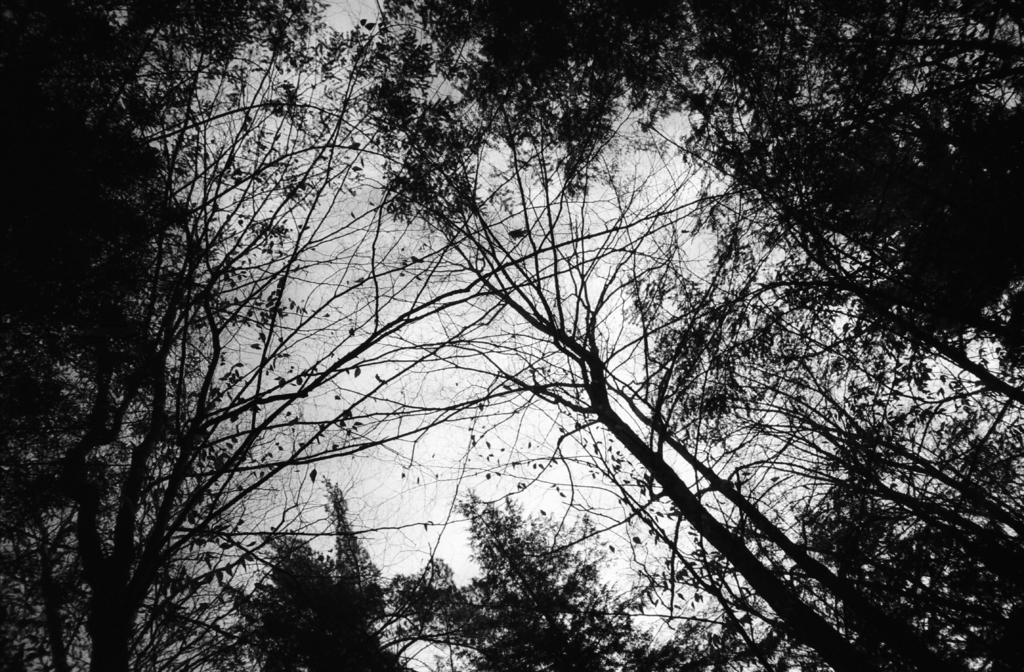What type of vegetation can be seen in the background of the image? There are trees visible in the background of the image. What else can be seen in the background of the image? The sky is visible in the background of the image. What degree does the engine of the car in the image have? There is no car present in the image, so it is not possible to determine the degree of its engine. 